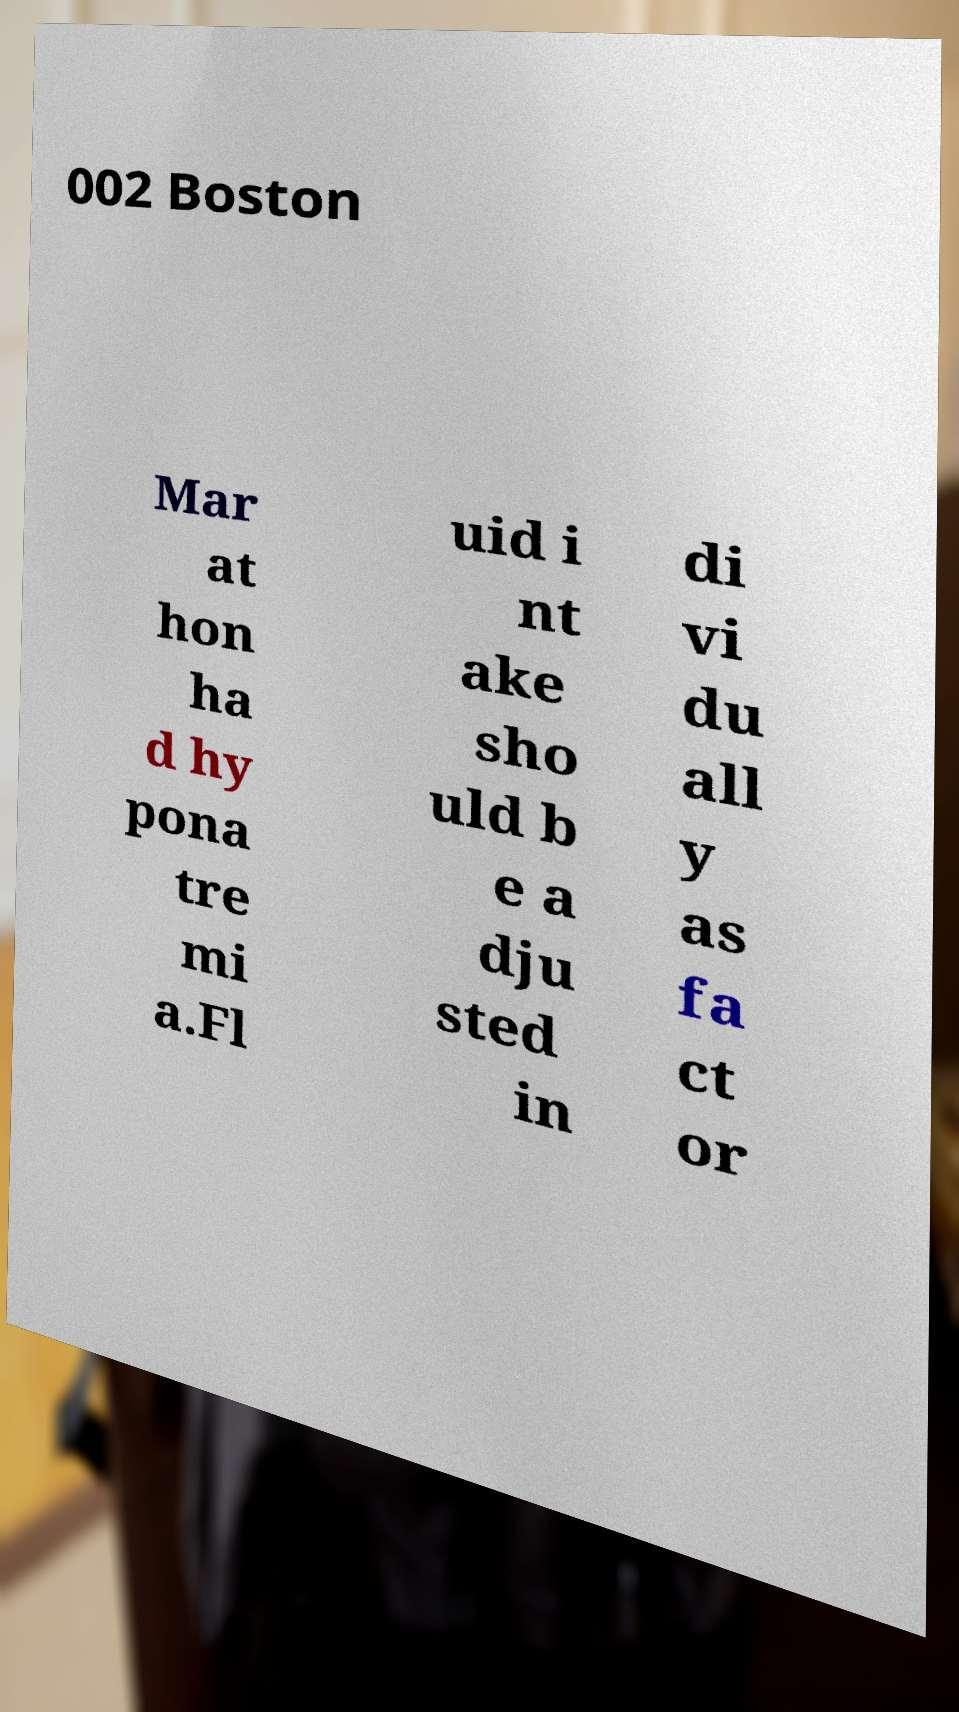I need the written content from this picture converted into text. Can you do that? 002 Boston Mar at hon ha d hy pona tre mi a.Fl uid i nt ake sho uld b e a dju sted in di vi du all y as fa ct or 